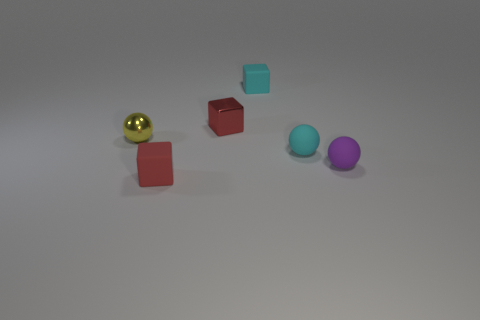Is there a small object?
Your answer should be compact. Yes. What number of other things are the same size as the purple matte thing?
Keep it short and to the point. 5. There is a shiny sphere; is its color the same as the small rubber sphere that is behind the purple matte thing?
Provide a short and direct response. No. What number of objects are either purple objects or cyan rubber objects?
Provide a short and direct response. 3. Is there anything else that is the same color as the tiny shiny ball?
Give a very brief answer. No. Is the small yellow thing made of the same material as the cyan object in front of the small yellow thing?
Your answer should be very brief. No. There is a small metal object to the left of the red cube that is behind the tiny yellow sphere; what is its shape?
Keep it short and to the point. Sphere. What is the shape of the tiny rubber thing that is both behind the tiny purple matte ball and in front of the small cyan matte cube?
Make the answer very short. Sphere. How many objects are red metal blocks or things that are in front of the yellow metallic thing?
Provide a succinct answer. 4. There is a small purple object that is the same shape as the small yellow object; what is it made of?
Offer a terse response. Rubber. 